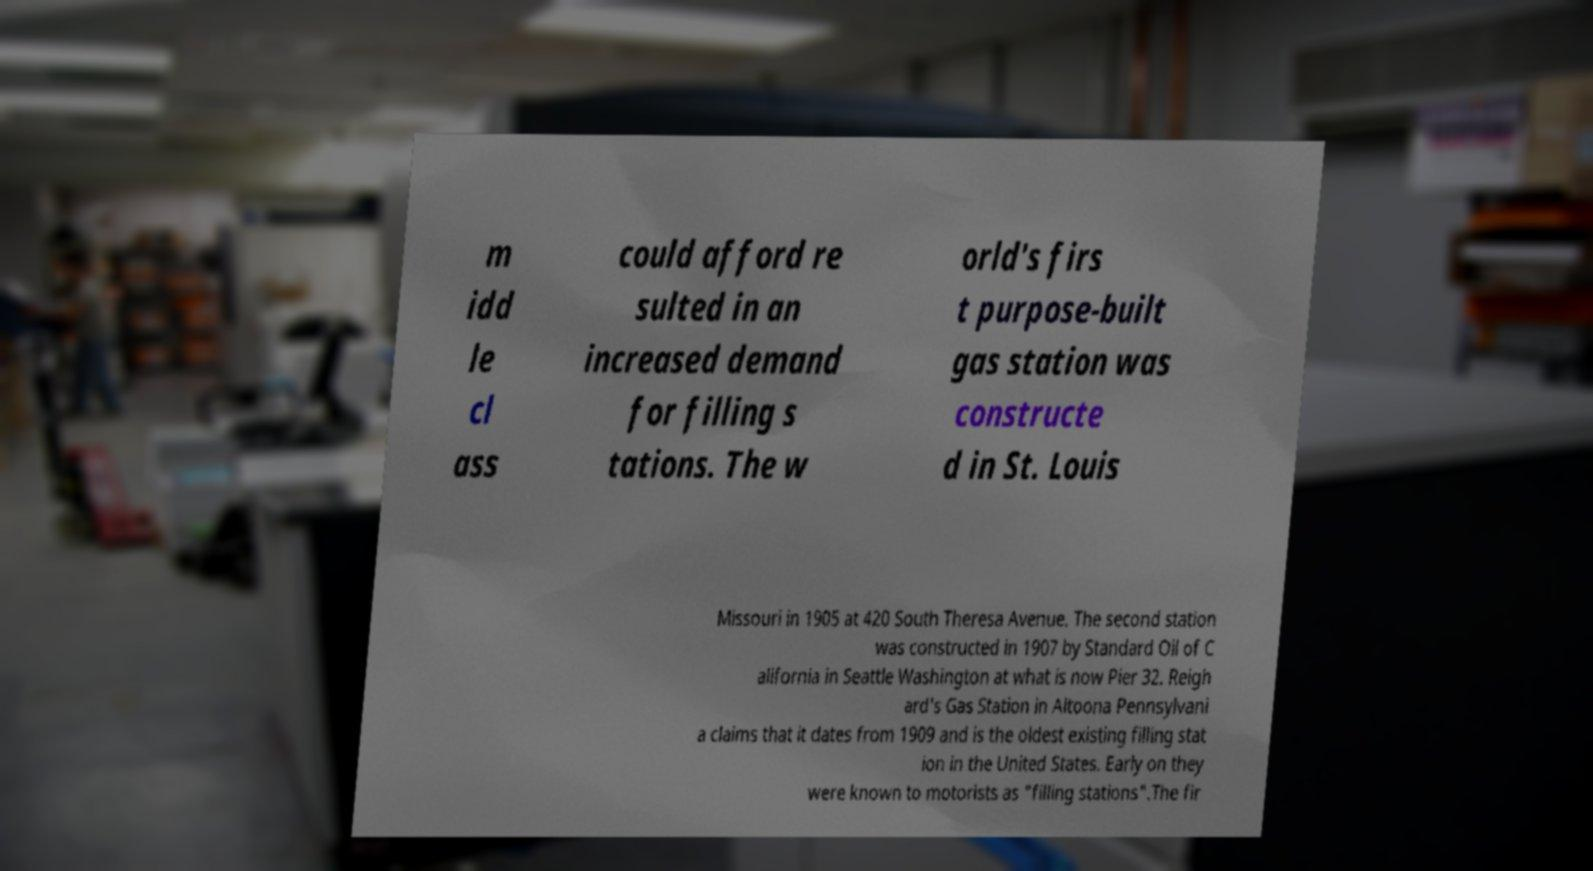Please read and relay the text visible in this image. What does it say? m idd le cl ass could afford re sulted in an increased demand for filling s tations. The w orld's firs t purpose-built gas station was constructe d in St. Louis Missouri in 1905 at 420 South Theresa Avenue. The second station was constructed in 1907 by Standard Oil of C alifornia in Seattle Washington at what is now Pier 32. Reigh ard's Gas Station in Altoona Pennsylvani a claims that it dates from 1909 and is the oldest existing filling stat ion in the United States. Early on they were known to motorists as "filling stations".The fir 